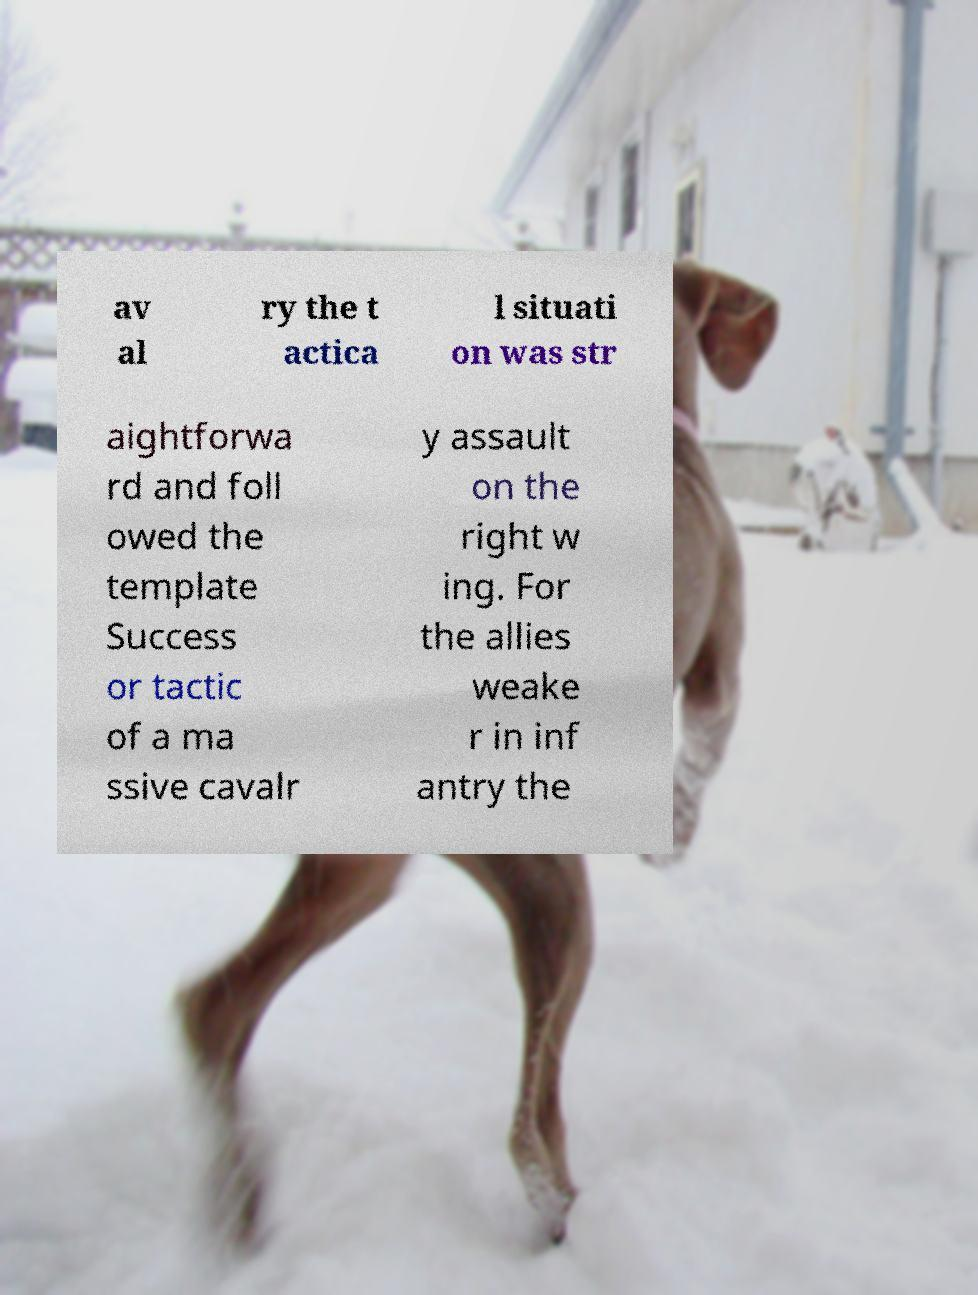There's text embedded in this image that I need extracted. Can you transcribe it verbatim? av al ry the t actica l situati on was str aightforwa rd and foll owed the template Success or tactic of a ma ssive cavalr y assault on the right w ing. For the allies weake r in inf antry the 